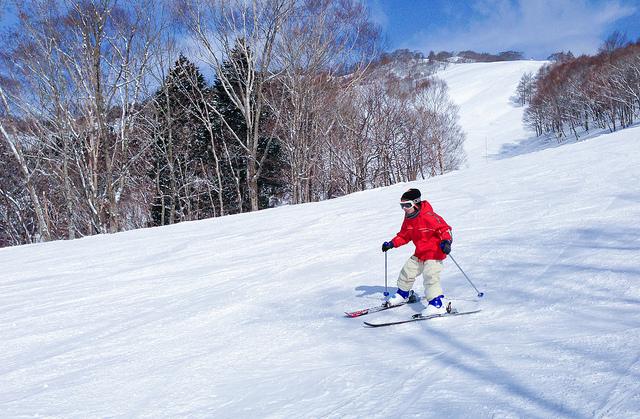Are the skis positioned to speed up or slow down?
Concise answer only. Slow down. What kind of weather does this area have?
Write a very short answer. Snow. What color is this person's jacket?
Keep it brief. Red. Is this a deep slope?
Short answer required. Yes. 